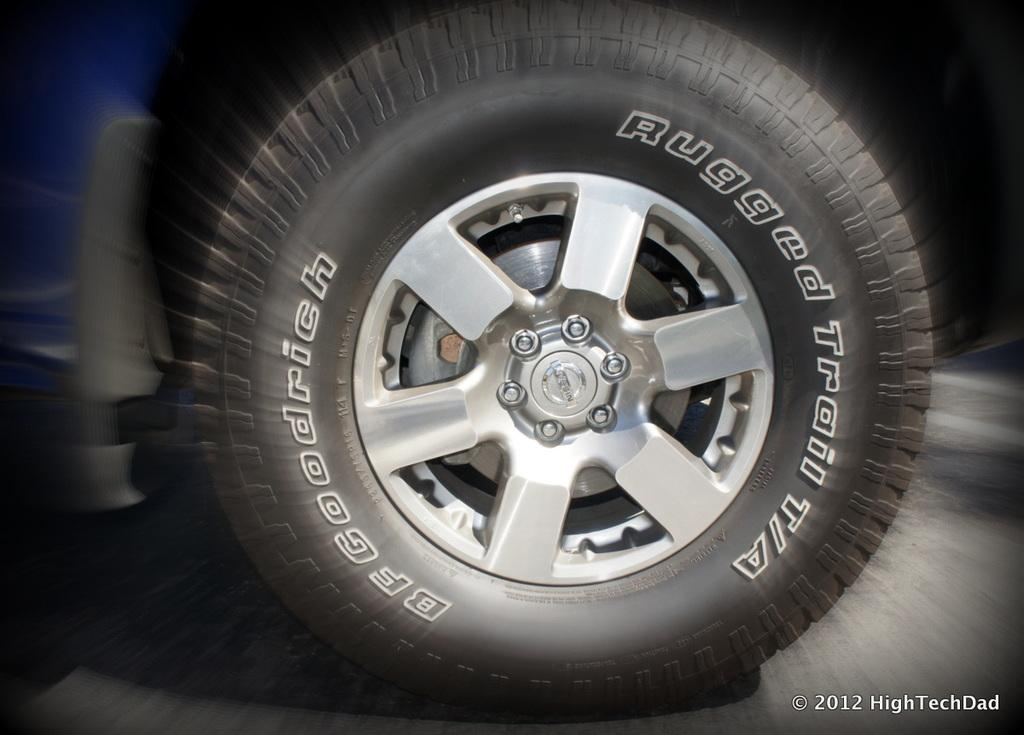What is the main subject in the middle of the image? There is a tyre in the middle of the image. Can you describe the area around the tyre? The area around the tyre is blurry. Is there any additional information or branding present in the image? Yes, there is a watermark at the bottom right side of the image. What type of bike apparatus is being used in the image? There is no bike or apparatus present in the image; it only features a tyre. How is the tyre being used in the image? The image does not show the tyre being used for any specific purpose, as it is the main subject and not an accessory or part of a larger object. 